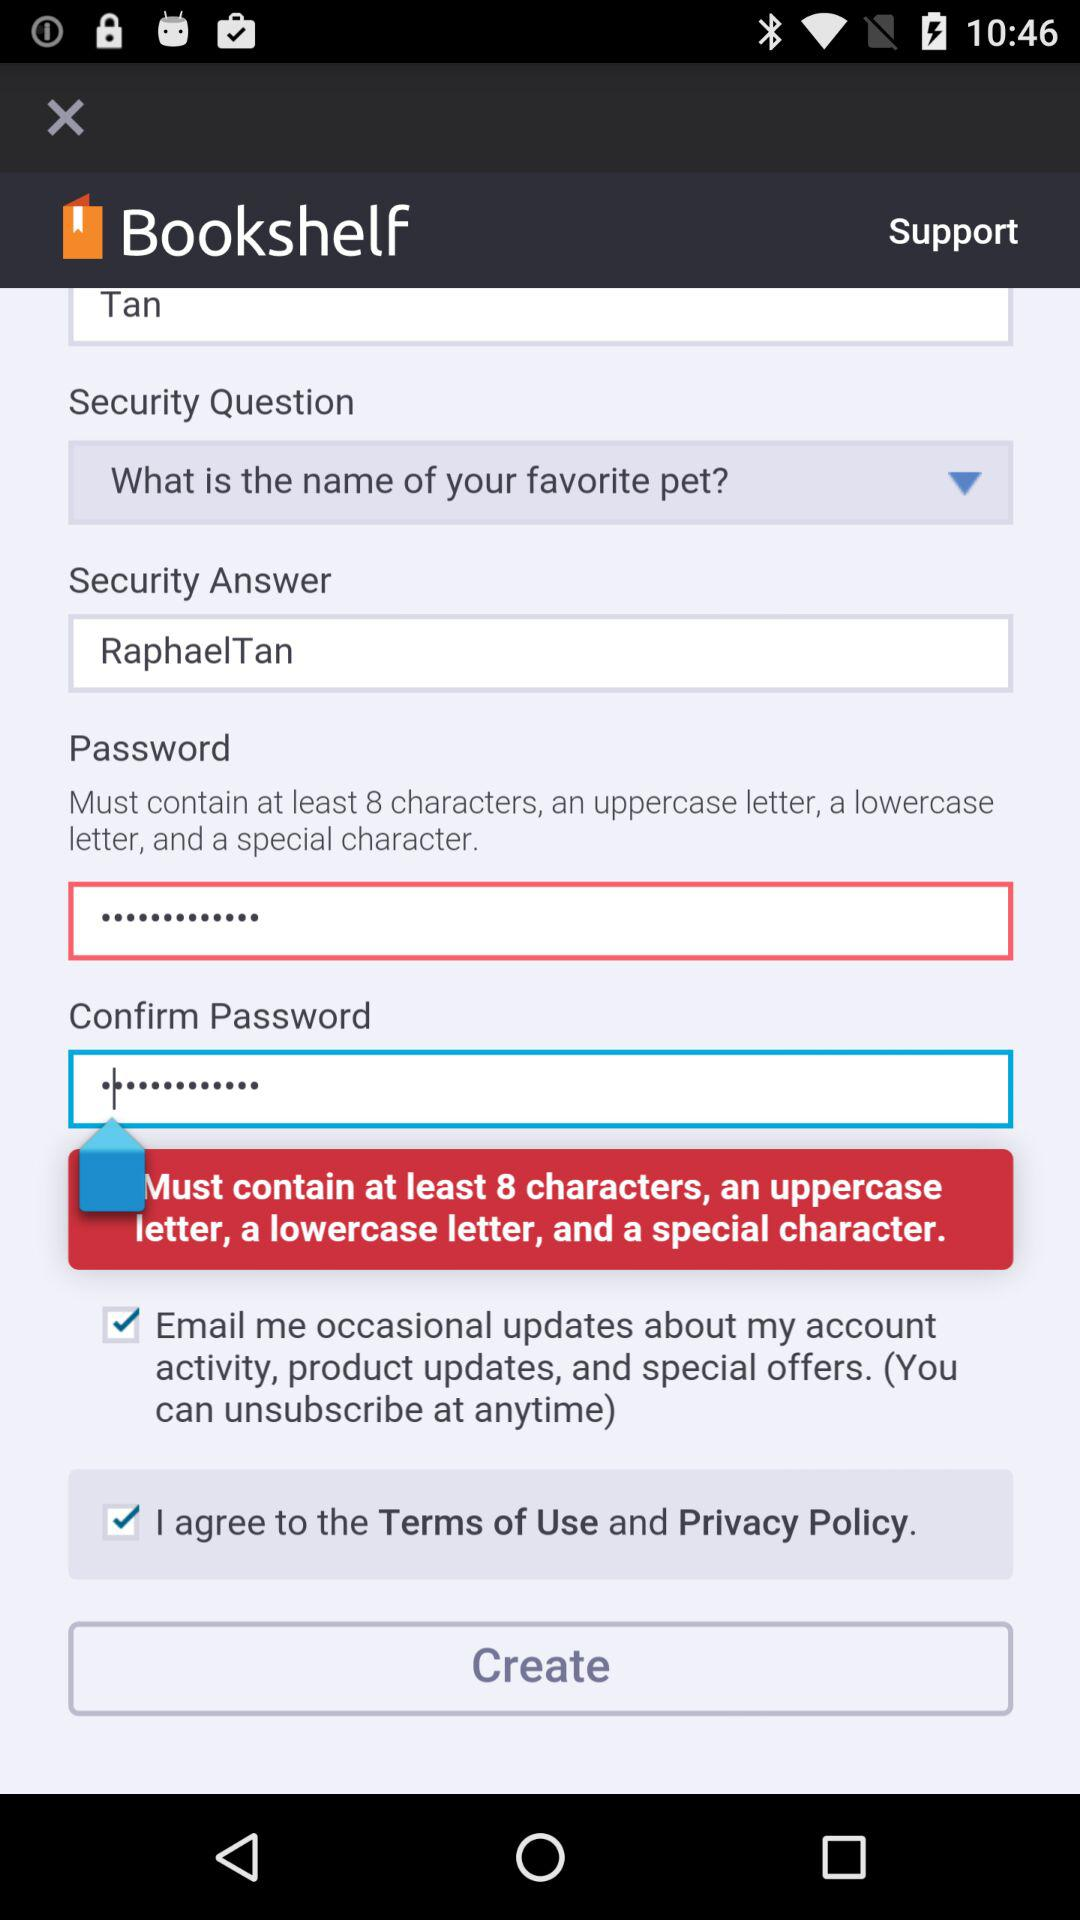What is the selected security permission? The selected security permissions are "Email me occasional updates about my account activity, product updates, and special offers. (You can unsubscribe at anytime)" and "I agree to the Terms of Use and Privacy Policy.". 